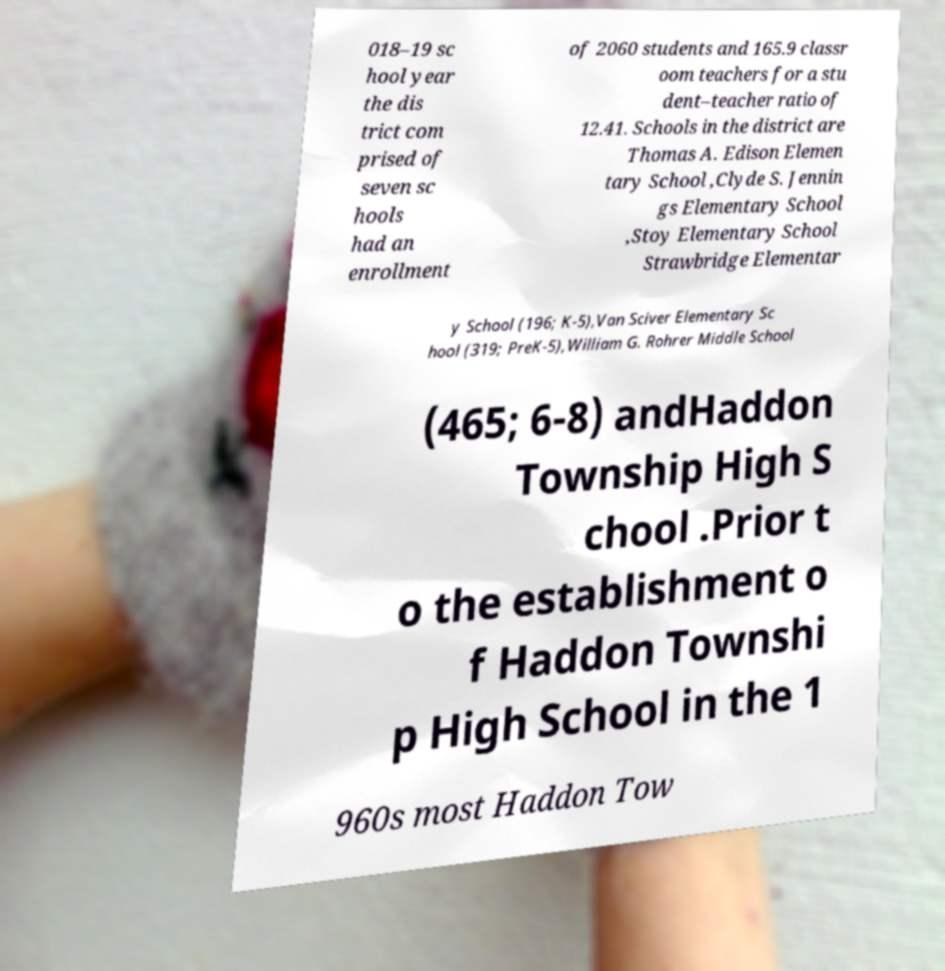What messages or text are displayed in this image? I need them in a readable, typed format. 018–19 sc hool year the dis trict com prised of seven sc hools had an enrollment of 2060 students and 165.9 classr oom teachers for a stu dent–teacher ratio of 12.41. Schools in the district are Thomas A. Edison Elemen tary School ,Clyde S. Jennin gs Elementary School ,Stoy Elementary School Strawbridge Elementar y School (196; K-5),Van Sciver Elementary Sc hool (319; PreK-5),William G. Rohrer Middle School (465; 6-8) andHaddon Township High S chool .Prior t o the establishment o f Haddon Townshi p High School in the 1 960s most Haddon Tow 